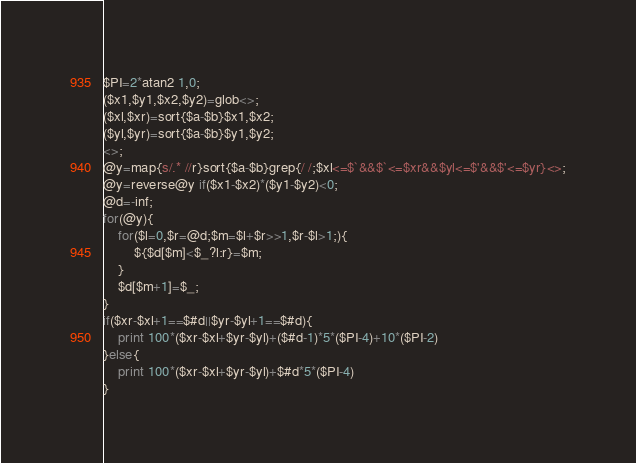<code> <loc_0><loc_0><loc_500><loc_500><_Perl_>$PI=2*atan2 1,0;
($x1,$y1,$x2,$y2)=glob<>;
($xl,$xr)=sort{$a-$b}$x1,$x2;
($yl,$yr)=sort{$a-$b}$y1,$y2;
<>;
@y=map{s/.* //r}sort{$a-$b}grep{/ /;$xl<=$`&&$`<=$xr&&$yl<=$'&&$'<=$yr}<>;
@y=reverse@y if($x1-$x2)*($y1-$y2)<0;
@d=-inf;
for(@y){
	for($l=0,$r=@d;$m=$l+$r>>1,$r-$l>1;){
		${$d[$m]<$_?l:r}=$m;
	}
	$d[$m+1]=$_;
}
if($xr-$xl+1==$#d||$yr-$yl+1==$#d){
	print 100*($xr-$xl+$yr-$yl)+($#d-1)*5*($PI-4)+10*($PI-2)
}else{
	print 100*($xr-$xl+$yr-$yl)+$#d*5*($PI-4)
}
</code> 